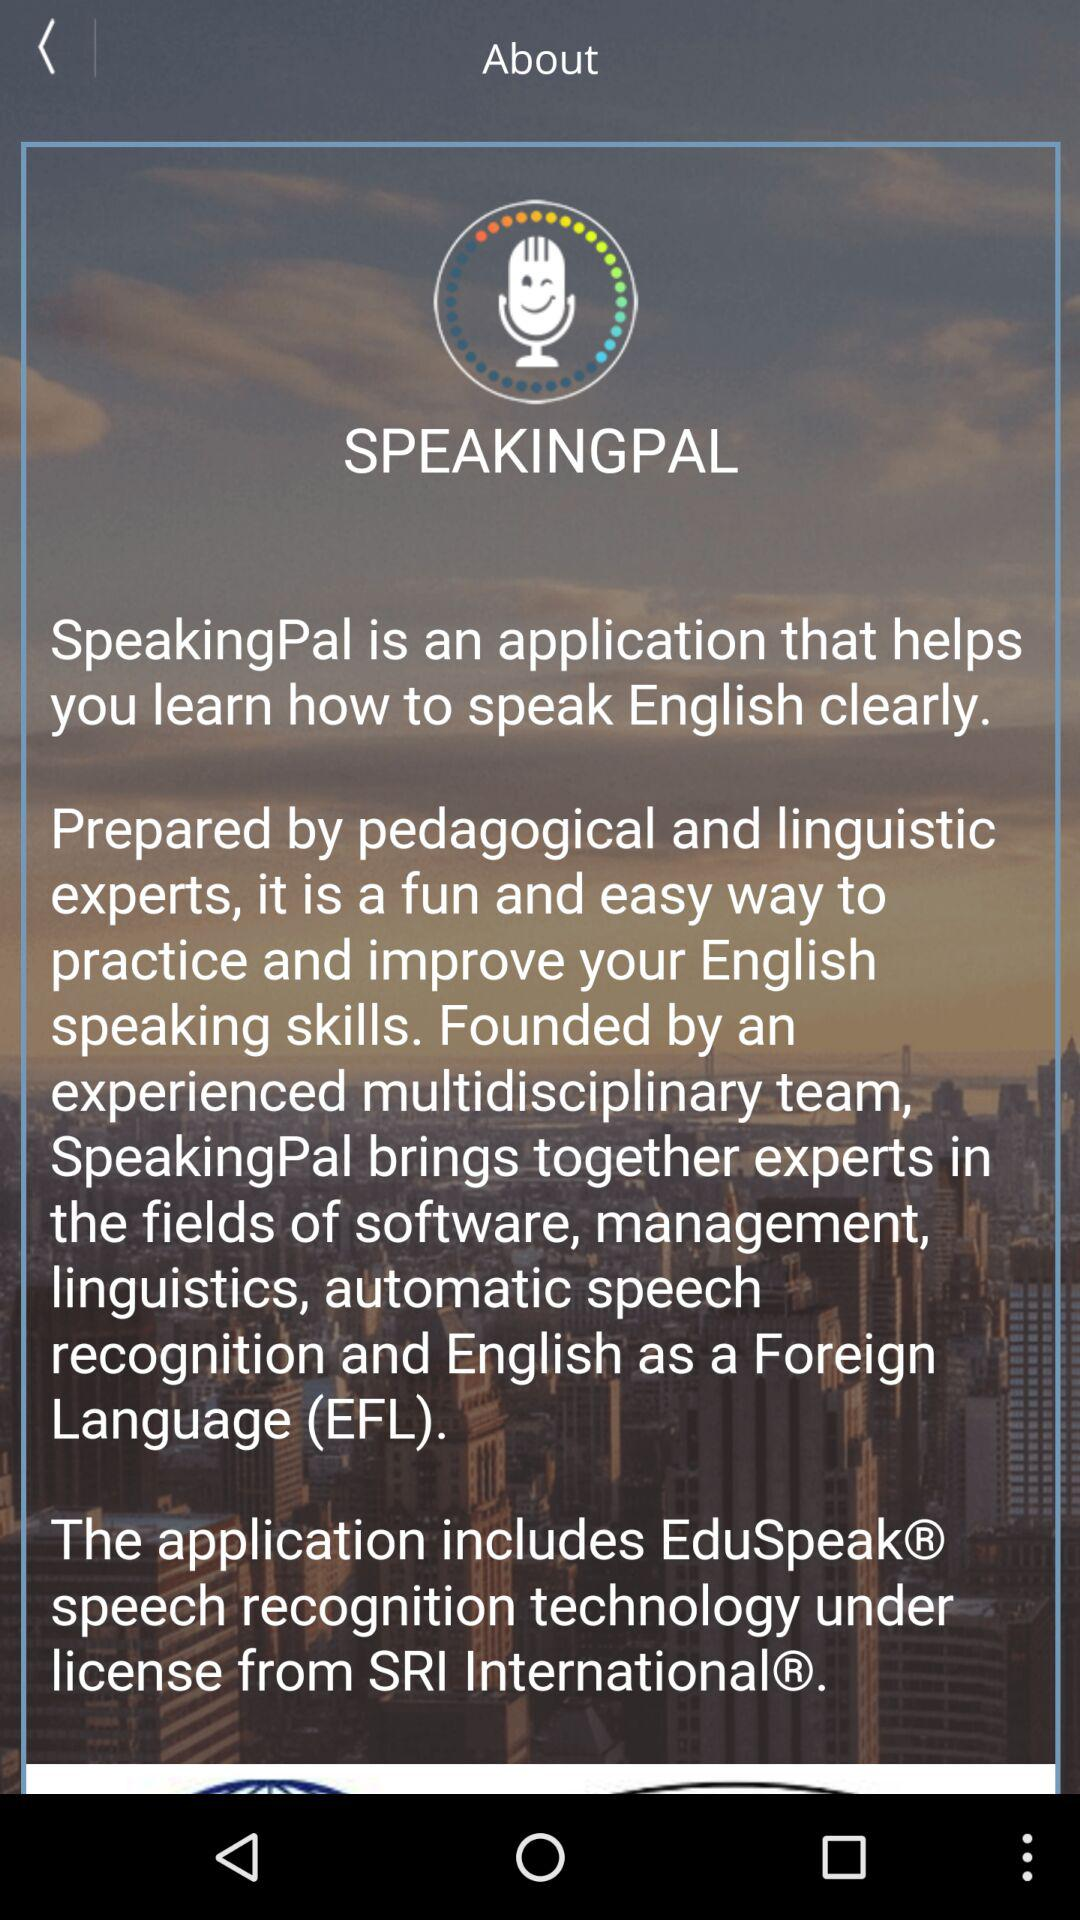What is the app name? The app name is "SPEAKINGPAL". 